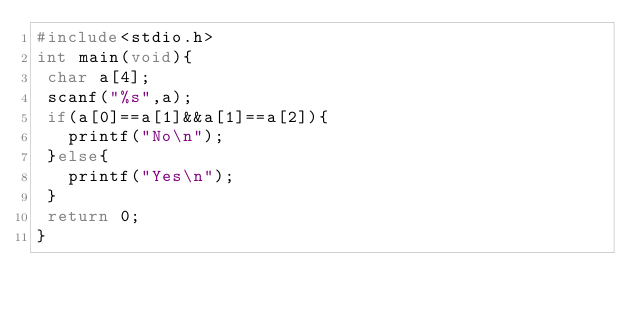<code> <loc_0><loc_0><loc_500><loc_500><_C_>#include<stdio.h>
int main(void){
 char a[4];
 scanf("%s",a);
 if(a[0]==a[1]&&a[1]==a[2]){
   printf("No\n");
 }else{
   printf("Yes\n");
 }
 return 0;
}
</code> 